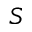Convert formula to latex. <formula><loc_0><loc_0><loc_500><loc_500>S</formula> 